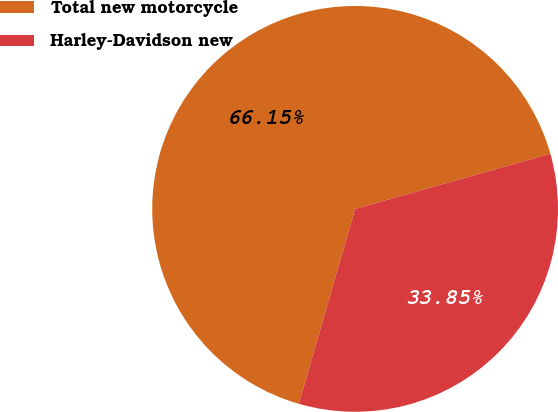Convert chart to OTSL. <chart><loc_0><loc_0><loc_500><loc_500><pie_chart><fcel>Total new motorcycle<fcel>Harley-Davidson new<nl><fcel>66.15%<fcel>33.85%<nl></chart> 